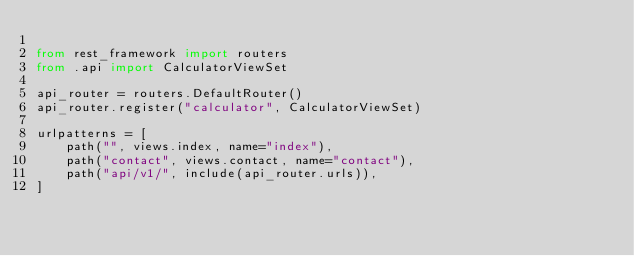<code> <loc_0><loc_0><loc_500><loc_500><_Python_>
from rest_framework import routers
from .api import CalculatorViewSet

api_router = routers.DefaultRouter()
api_router.register("calculator", CalculatorViewSet)

urlpatterns = [
    path("", views.index, name="index"),
    path("contact", views.contact, name="contact"),
    path("api/v1/", include(api_router.urls)),
]
</code> 